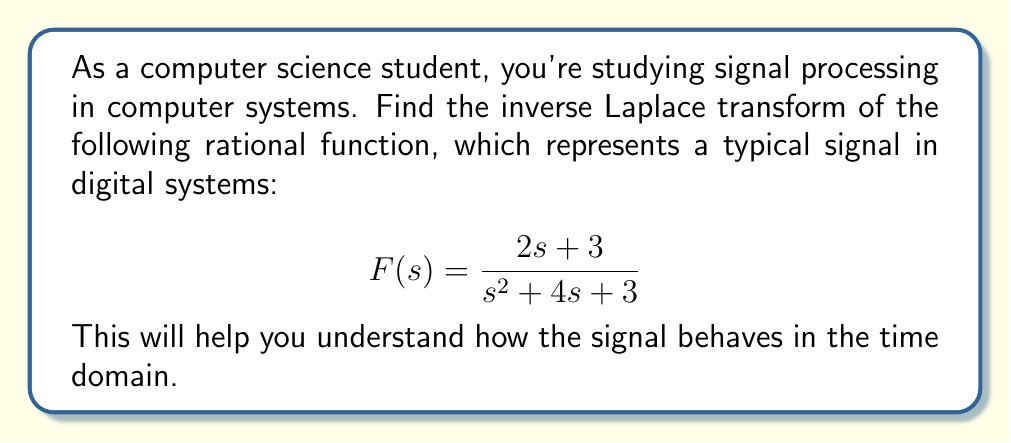Provide a solution to this math problem. To find the inverse Laplace transform of this rational function, we'll follow these steps:

1) First, we need to factor the denominator:
   $$s^2 + 4s + 3 = (s + 1)(s + 3)$$

2) Now, we can express F(s) as a sum of partial fractions:
   $$F(s) = \frac{A}{s + 1} + \frac{B}{s + 3}$$

3) To find A and B, we multiply both sides by $(s + 1)(s + 3)$:
   $$2s + 3 = A(s + 3) + B(s + 1)$$

4) Equate coefficients:
   For s: $2 = A + B$
   For constant term: $3 = 3A + B$

5) Solve these equations:
   $3 = 3A + B$
   $2 = A + B$
   Subtracting, we get: $1 = 2A$, so $A = \frac{1}{2}$
   Then, $B = 2 - A = 2 - \frac{1}{2} = \frac{3}{2}$

6) Therefore, our partial fraction decomposition is:
   $$F(s) = \frac{1/2}{s + 1} + \frac{3/2}{s + 3}$$

7) Now, we can use the inverse Laplace transform property:
   $$\mathcal{L}^{-1}\left\{\frac{1}{s + a}\right\} = e^{-at}$$

8) Applying this to our function:
   $$\mathcal{L}^{-1}\{F(s)\} = \frac{1}{2}e^{-t} + \frac{3}{2}e^{-3t}$$

This is our final result in the time domain.
Answer: $$f(t) = \frac{1}{2}e^{-t} + \frac{3}{2}e^{-3t}$$ 